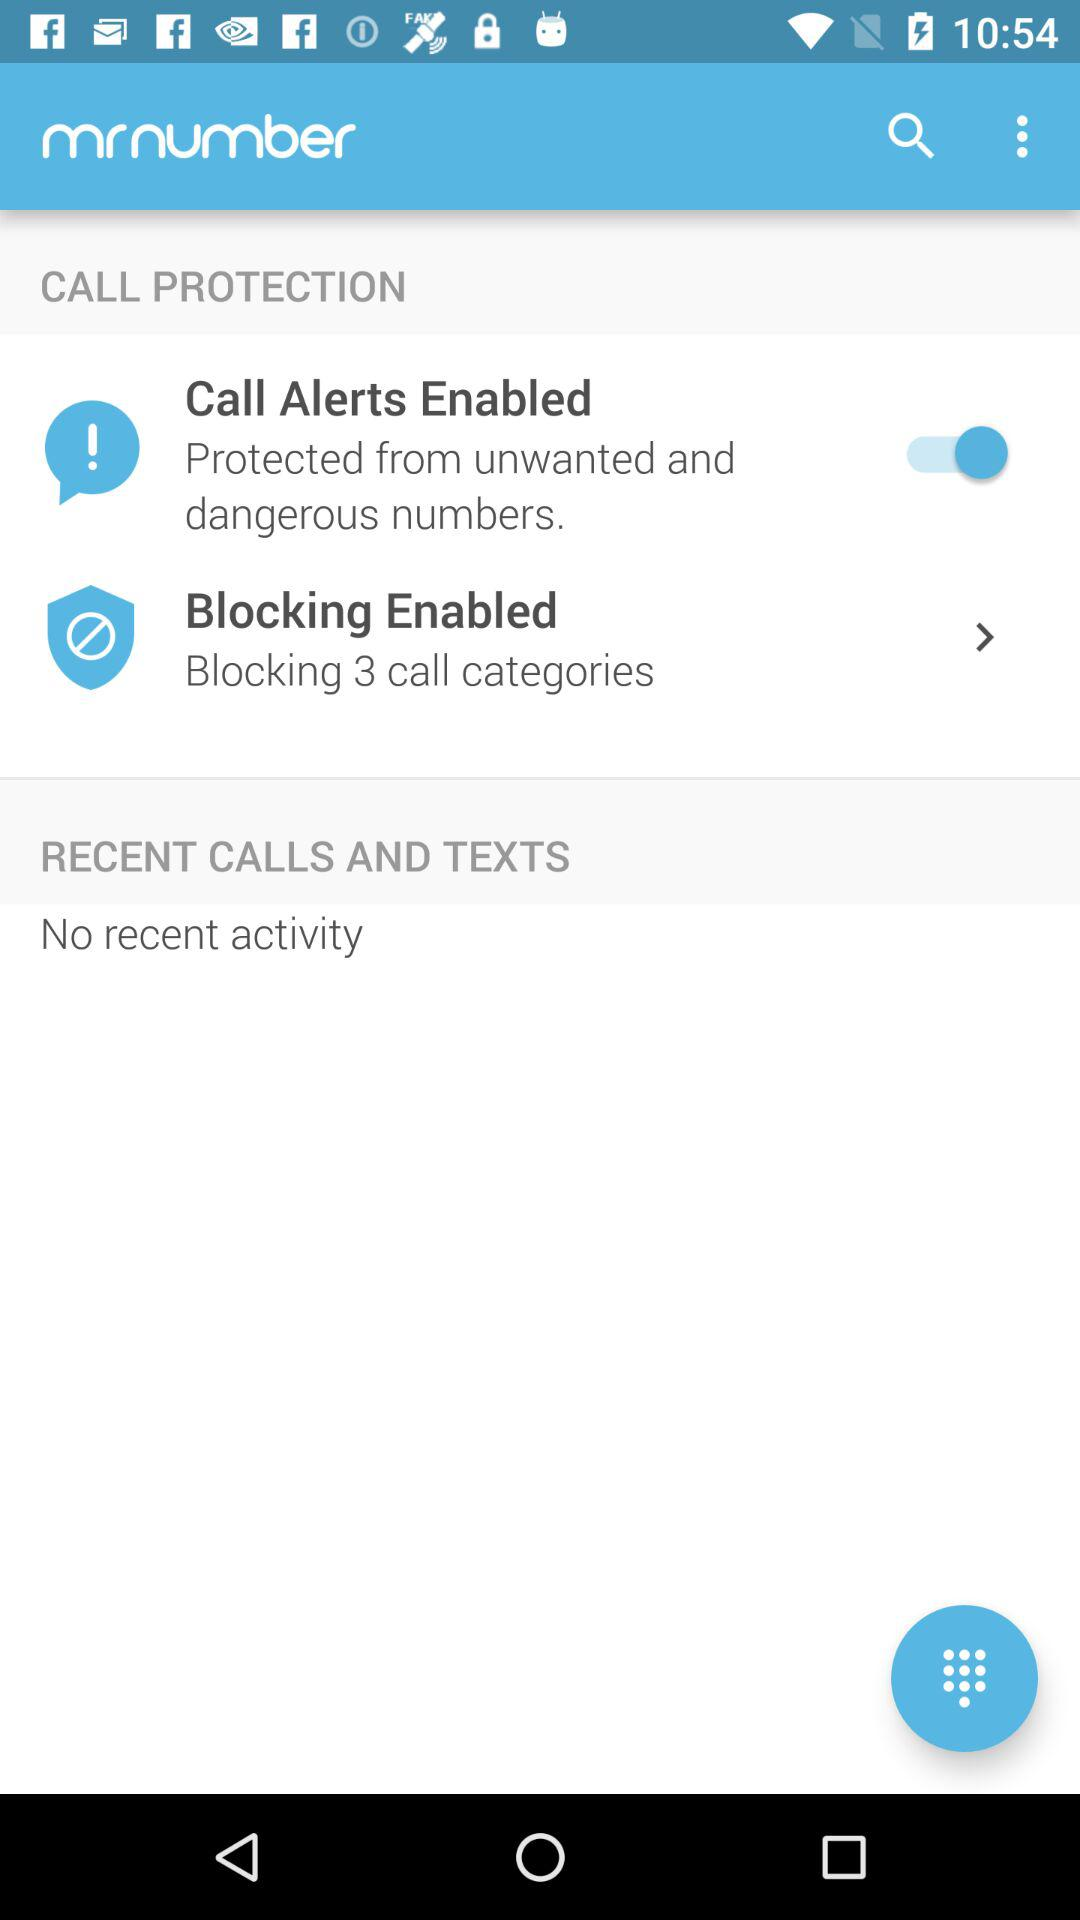How many call categories are blocked?
Answer the question using a single word or phrase. 3 